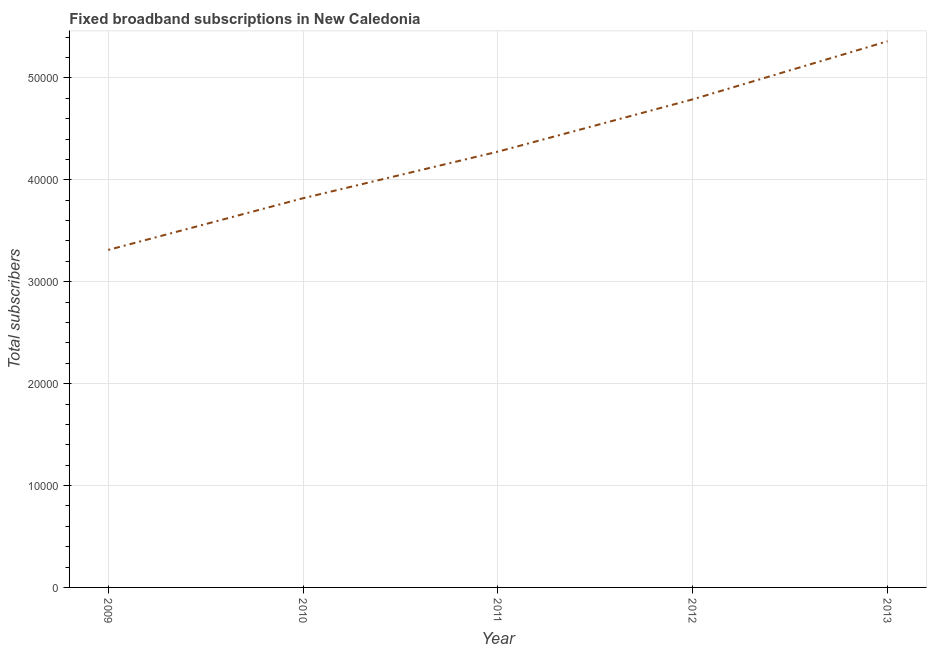What is the total number of fixed broadband subscriptions in 2012?
Make the answer very short. 4.79e+04. Across all years, what is the maximum total number of fixed broadband subscriptions?
Give a very brief answer. 5.36e+04. Across all years, what is the minimum total number of fixed broadband subscriptions?
Your response must be concise. 3.31e+04. In which year was the total number of fixed broadband subscriptions maximum?
Make the answer very short. 2013. What is the sum of the total number of fixed broadband subscriptions?
Ensure brevity in your answer.  2.16e+05. What is the difference between the total number of fixed broadband subscriptions in 2012 and 2013?
Provide a succinct answer. -5700. What is the average total number of fixed broadband subscriptions per year?
Provide a short and direct response. 4.31e+04. What is the median total number of fixed broadband subscriptions?
Your response must be concise. 4.28e+04. In how many years, is the total number of fixed broadband subscriptions greater than 10000 ?
Keep it short and to the point. 5. Do a majority of the years between 2013 and 2010 (inclusive) have total number of fixed broadband subscriptions greater than 12000 ?
Provide a short and direct response. Yes. What is the ratio of the total number of fixed broadband subscriptions in 2011 to that in 2012?
Make the answer very short. 0.89. Is the total number of fixed broadband subscriptions in 2011 less than that in 2013?
Give a very brief answer. Yes. Is the difference between the total number of fixed broadband subscriptions in 2009 and 2011 greater than the difference between any two years?
Provide a short and direct response. No. What is the difference between the highest and the second highest total number of fixed broadband subscriptions?
Your answer should be compact. 5700. Is the sum of the total number of fixed broadband subscriptions in 2009 and 2010 greater than the maximum total number of fixed broadband subscriptions across all years?
Provide a short and direct response. Yes. What is the difference between the highest and the lowest total number of fixed broadband subscriptions?
Your answer should be compact. 2.05e+04. In how many years, is the total number of fixed broadband subscriptions greater than the average total number of fixed broadband subscriptions taken over all years?
Provide a succinct answer. 2. How many lines are there?
Ensure brevity in your answer.  1. What is the title of the graph?
Give a very brief answer. Fixed broadband subscriptions in New Caledonia. What is the label or title of the X-axis?
Your response must be concise. Year. What is the label or title of the Y-axis?
Provide a short and direct response. Total subscribers. What is the Total subscribers of 2009?
Your answer should be very brief. 3.31e+04. What is the Total subscribers of 2010?
Offer a terse response. 3.82e+04. What is the Total subscribers in 2011?
Keep it short and to the point. 4.28e+04. What is the Total subscribers of 2012?
Make the answer very short. 4.79e+04. What is the Total subscribers of 2013?
Provide a succinct answer. 5.36e+04. What is the difference between the Total subscribers in 2009 and 2010?
Your response must be concise. -5075. What is the difference between the Total subscribers in 2009 and 2011?
Your response must be concise. -9646. What is the difference between the Total subscribers in 2009 and 2012?
Give a very brief answer. -1.48e+04. What is the difference between the Total subscribers in 2009 and 2013?
Your answer should be compact. -2.05e+04. What is the difference between the Total subscribers in 2010 and 2011?
Offer a very short reply. -4571. What is the difference between the Total subscribers in 2010 and 2012?
Keep it short and to the point. -9704. What is the difference between the Total subscribers in 2010 and 2013?
Give a very brief answer. -1.54e+04. What is the difference between the Total subscribers in 2011 and 2012?
Provide a succinct answer. -5133. What is the difference between the Total subscribers in 2011 and 2013?
Your response must be concise. -1.08e+04. What is the difference between the Total subscribers in 2012 and 2013?
Keep it short and to the point. -5700. What is the ratio of the Total subscribers in 2009 to that in 2010?
Give a very brief answer. 0.87. What is the ratio of the Total subscribers in 2009 to that in 2011?
Offer a terse response. 0.77. What is the ratio of the Total subscribers in 2009 to that in 2012?
Keep it short and to the point. 0.69. What is the ratio of the Total subscribers in 2009 to that in 2013?
Make the answer very short. 0.62. What is the ratio of the Total subscribers in 2010 to that in 2011?
Your answer should be compact. 0.89. What is the ratio of the Total subscribers in 2010 to that in 2012?
Offer a very short reply. 0.8. What is the ratio of the Total subscribers in 2010 to that in 2013?
Your answer should be very brief. 0.71. What is the ratio of the Total subscribers in 2011 to that in 2012?
Provide a short and direct response. 0.89. What is the ratio of the Total subscribers in 2011 to that in 2013?
Give a very brief answer. 0.8. What is the ratio of the Total subscribers in 2012 to that in 2013?
Your answer should be compact. 0.89. 